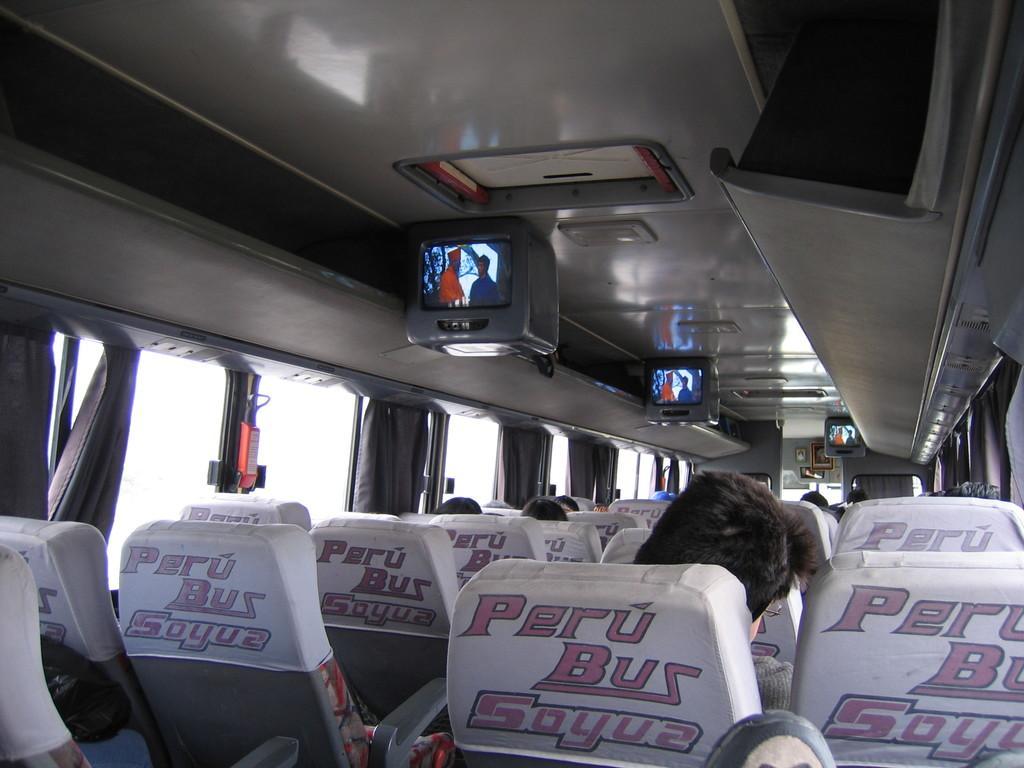Describe this image in one or two sentences. In this image we can see persons sitting on the seats of a motor vehicle, display screens and curtains to the windows. 